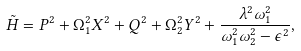Convert formula to latex. <formula><loc_0><loc_0><loc_500><loc_500>\tilde { H } = P ^ { 2 } + \Omega _ { 1 } ^ { 2 } X ^ { 2 } + Q ^ { 2 } + \Omega _ { 2 } ^ { 2 } Y ^ { 2 } + \frac { \lambda ^ { 2 } \omega _ { 1 } ^ { 2 } } { \omega _ { 1 } ^ { 2 } \omega _ { 2 } ^ { 2 } - \epsilon ^ { 2 } } ,</formula> 